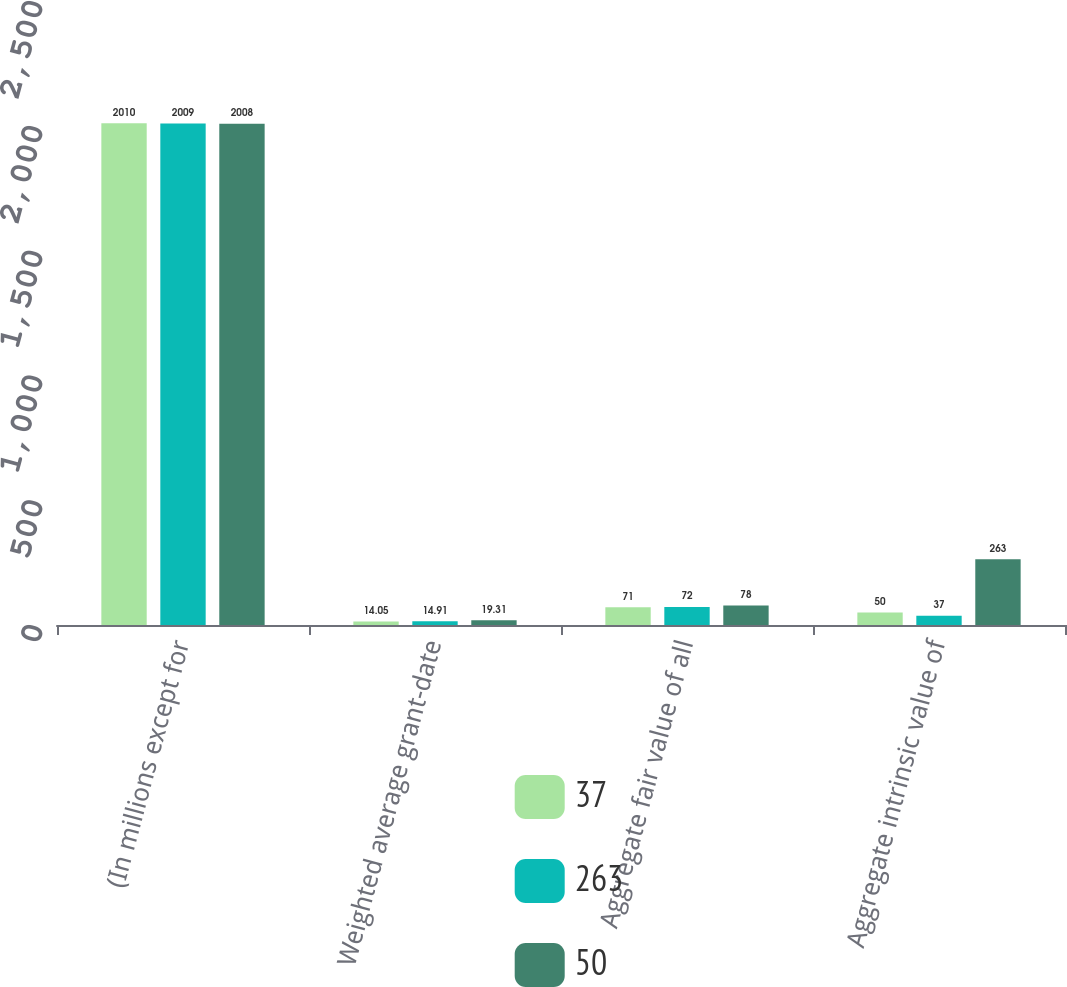Convert chart. <chart><loc_0><loc_0><loc_500><loc_500><stacked_bar_chart><ecel><fcel>(In millions except for<fcel>Weighted average grant-date<fcel>Aggregate fair value of all<fcel>Aggregate intrinsic value of<nl><fcel>37<fcel>2010<fcel>14.05<fcel>71<fcel>50<nl><fcel>263<fcel>2009<fcel>14.91<fcel>72<fcel>37<nl><fcel>50<fcel>2008<fcel>19.31<fcel>78<fcel>263<nl></chart> 